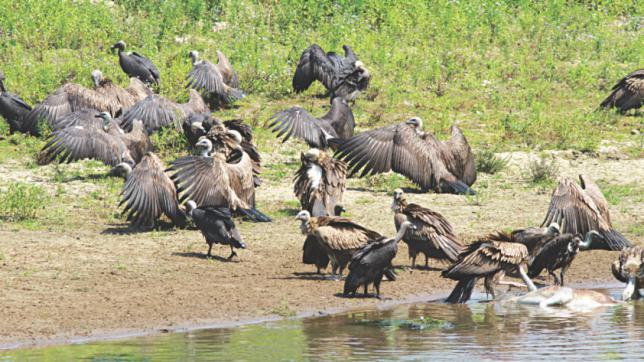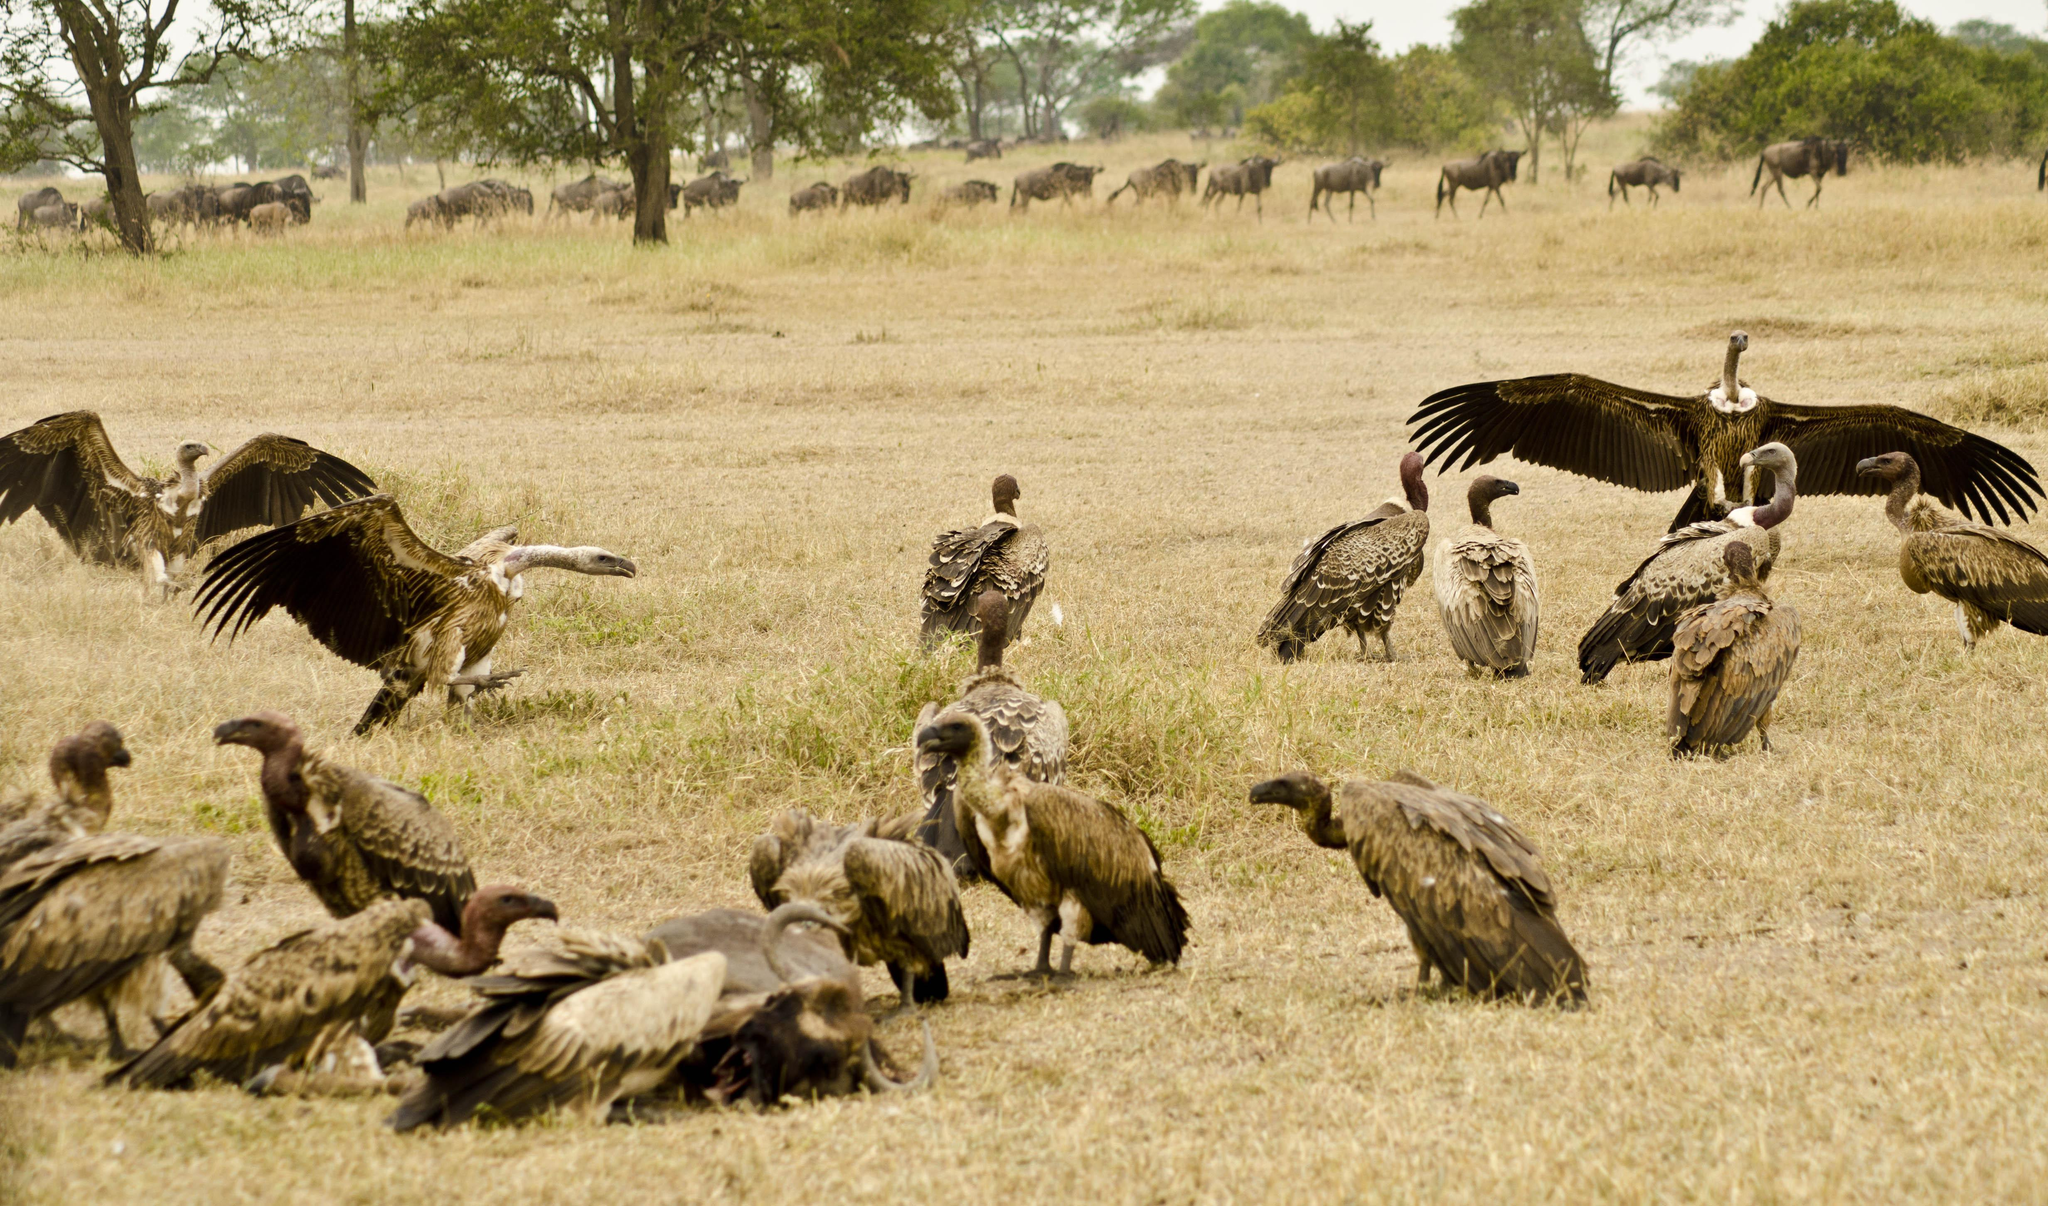The first image is the image on the left, the second image is the image on the right. Examine the images to the left and right. Is the description "There is at least one bird with extended wings in the image on the right." accurate? Answer yes or no. Yes. 